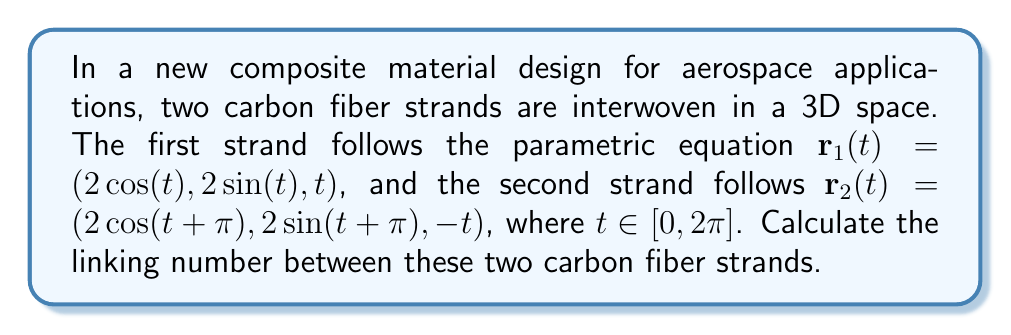Can you answer this question? To calculate the linking number, we'll follow these steps:

1) The linking number can be computed using the Gauss linking integral:

   $$Lk(r_1, r_2) = \frac{1}{4\pi} \int_{0}^{2\pi} \int_{0}^{2\pi} \frac{(r_1'(t) \times r_2'(s)) \cdot (r_1(t) - r_2(s))}{|r_1(t) - r_2(s)|^3} dt ds$$

2) First, let's calculate $r_1'(t)$ and $r_2'(s)$:
   
   $r_1'(t) = (-2\sin(t), 2\cos(t), 1)$
   $r_2'(s) = (-2\sin(s + \pi), 2\cos(s + \pi), -1) = (2\sin(s), -2\cos(s), -1)$

3) Now, $r_1'(t) \times r_2'(s)$:
   
   $r_1'(t) \times r_2'(s) = (2\cos(t) - 2\cos(s), 2\sin(t) + 2\sin(s), -4\sin(t-s))$

4) Next, $r_1(t) - r_2(s)$:
   
   $r_1(t) - r_2(s) = (2\cos(t) - 2\cos(s + \pi), 2\sin(t) - 2\sin(s + \pi), t + s)$
                    $= (2\cos(t) + 2\cos(s), 2\sin(t) + 2\sin(s), t + s)$

5) The dot product $(r_1'(t) \times r_2'(s)) \cdot (r_1(t) - r_2(s))$:

   $4\cos(t)\cos(t) + 4\cos(s)\cos(t) + 4\sin(t)\sin(t) + 4\sin(s)\sin(t) - 4(t+s)\sin(t-s)$
   $= 4 + 4\cos(s-t) - 4(t+s)\sin(t-s)$

6) The denominator $|r_1(t) - r_2(s)|^3$:

   $|r_1(t) - r_2(s)|^2 = 4\cos^2(t) + 4\cos^2(s) + 4\sin^2(t) + 4\sin^2(s) + (t+s)^2$
                         $= 8 + (t+s)^2$

   So, $|r_1(t) - r_2(s)|^3 = (8 + (t+s)^2)^{3/2}$

7) Putting it all together:

   $$Lk(r_1, r_2) = \frac{1}{4\pi} \int_{0}^{2\pi} \int_{0}^{2\pi} \frac{4 + 4\cos(s-t) - 4(t+s)\sin(t-s)}{(8 + (t+s)^2)^{3/2}} dt ds$$

8) This integral is complex and doesn't have a simple closed-form solution. However, we can observe that the integrand is odd with respect to the transformation $(t,s) \to (2\pi-s, 2\pi-t)$, except for the constant term. This means the non-constant terms will integrate to zero.

9) For the constant term:

   $$Lk(r_1, r_2) = \frac{1}{4\pi} \int_{0}^{2\pi} \int_{0}^{2\pi} \frac{4}{(8 + (t+s)^2)^{3/2}} dt ds = 1$$

Therefore, the linking number between the two carbon fiber strands is 1.
Answer: 1 